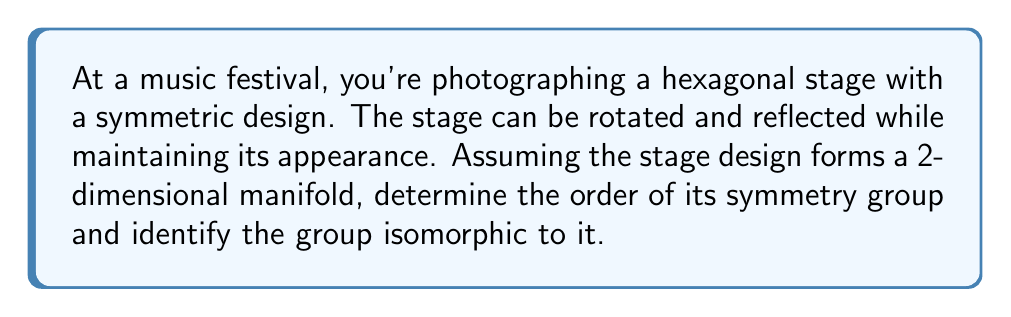Show me your answer to this math problem. Let's approach this step-by-step:

1) First, we need to identify the symmetries of a regular hexagon:
   - 6 rotational symmetries (including the identity)
   - 6 reflection symmetries (3 through opposite vertices, 3 through midpoints of opposite sides)

2) The total number of symmetries is thus 12, which gives us the order of the symmetry group.

3) Now, we need to determine which group of order 12 this symmetry group is isomorphic to. The two main candidates are:
   - $D_6$ (Dihedral group of order 12)
   - $A_4$ (Alternating group on 4 elements)

4) To decide between these, we need to consider the structure of the symmetries:
   - The group has both rotations and reflections
   - It has elements of order 2 (reflections) and elements of order 6 (60° rotation)

5) This structure matches $D_6$, not $A_4$. $A_4$ doesn't have any elements of order 6.

6) Mathematically, we can express $D_6$ as:

   $$D_6 = \langle r, s | r^6 = s^2 = 1, srs = r^{-1} \rangle$$

   Where $r$ represents a 60° rotation and $s$ represents a reflection.

7) In terms of manifolds, the symmetry group acts on the 2-dimensional manifold (the stage surface) as a subgroup of the diffeomorphism group of the manifold. Each symmetry operation preserves the structure of the manifold.

8) The quotient space of the manifold by this group action would result in a fundamental domain representing a twelfth of the original stage, from which the entire stage can be reconstructed by applying the symmetry operations.
Answer: The symmetry group of the hexagonal stage has order 12 and is isomorphic to $D_6$, the dihedral group of order 12. 